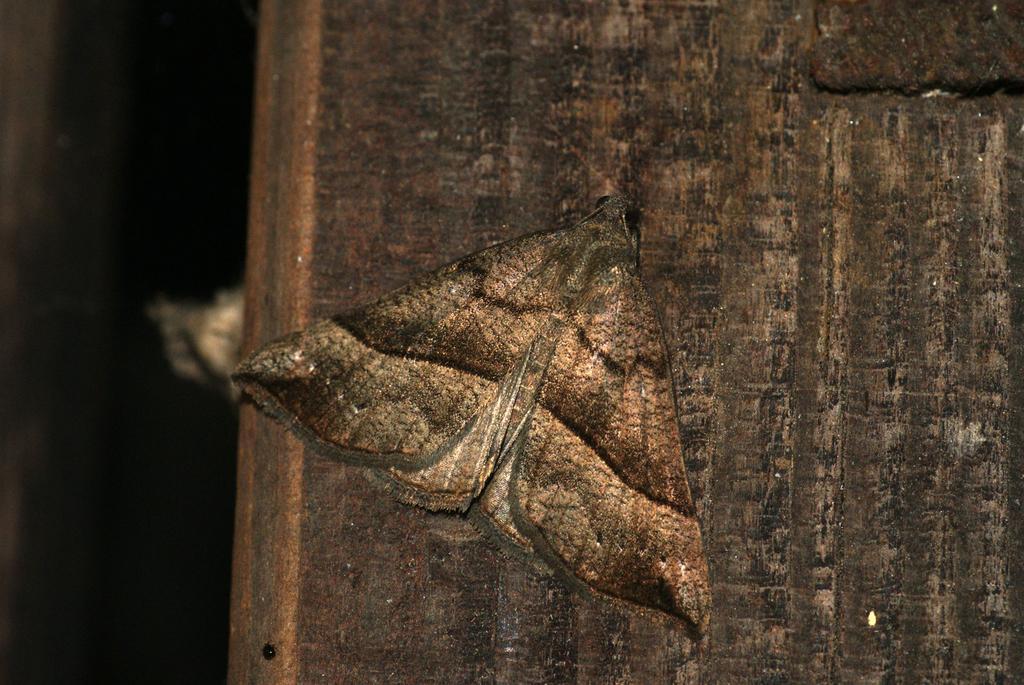How would you summarize this image in a sentence or two? In this image we can see a butterfly on a wooden surface. 